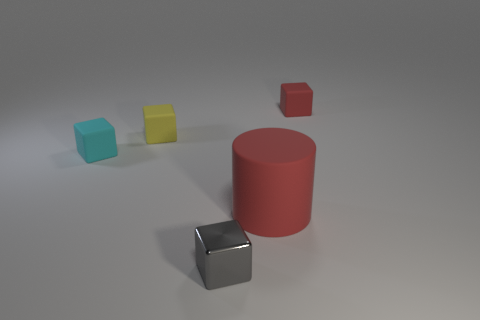Is there anything else that has the same size as the red cylinder?
Offer a terse response. No. What is the shape of the big matte object?
Provide a succinct answer. Cylinder. Do the large matte thing and the small metallic object have the same color?
Your answer should be compact. No. There is a shiny block that is the same size as the yellow rubber block; what color is it?
Offer a terse response. Gray. How many cyan objects are small matte cubes or matte objects?
Provide a succinct answer. 1. Are there more blocks than big red metallic objects?
Your answer should be compact. Yes. There is a thing that is behind the yellow object; is its size the same as the yellow matte block behind the big red matte object?
Give a very brief answer. Yes. There is a tiny rubber object that is to the right of the red object to the left of the red object that is behind the large cylinder; what is its color?
Your answer should be very brief. Red. Is there another small metal object of the same shape as the tiny red thing?
Offer a terse response. Yes. Is the number of large red rubber cylinders that are behind the red cylinder greater than the number of yellow matte blocks?
Provide a short and direct response. No. 